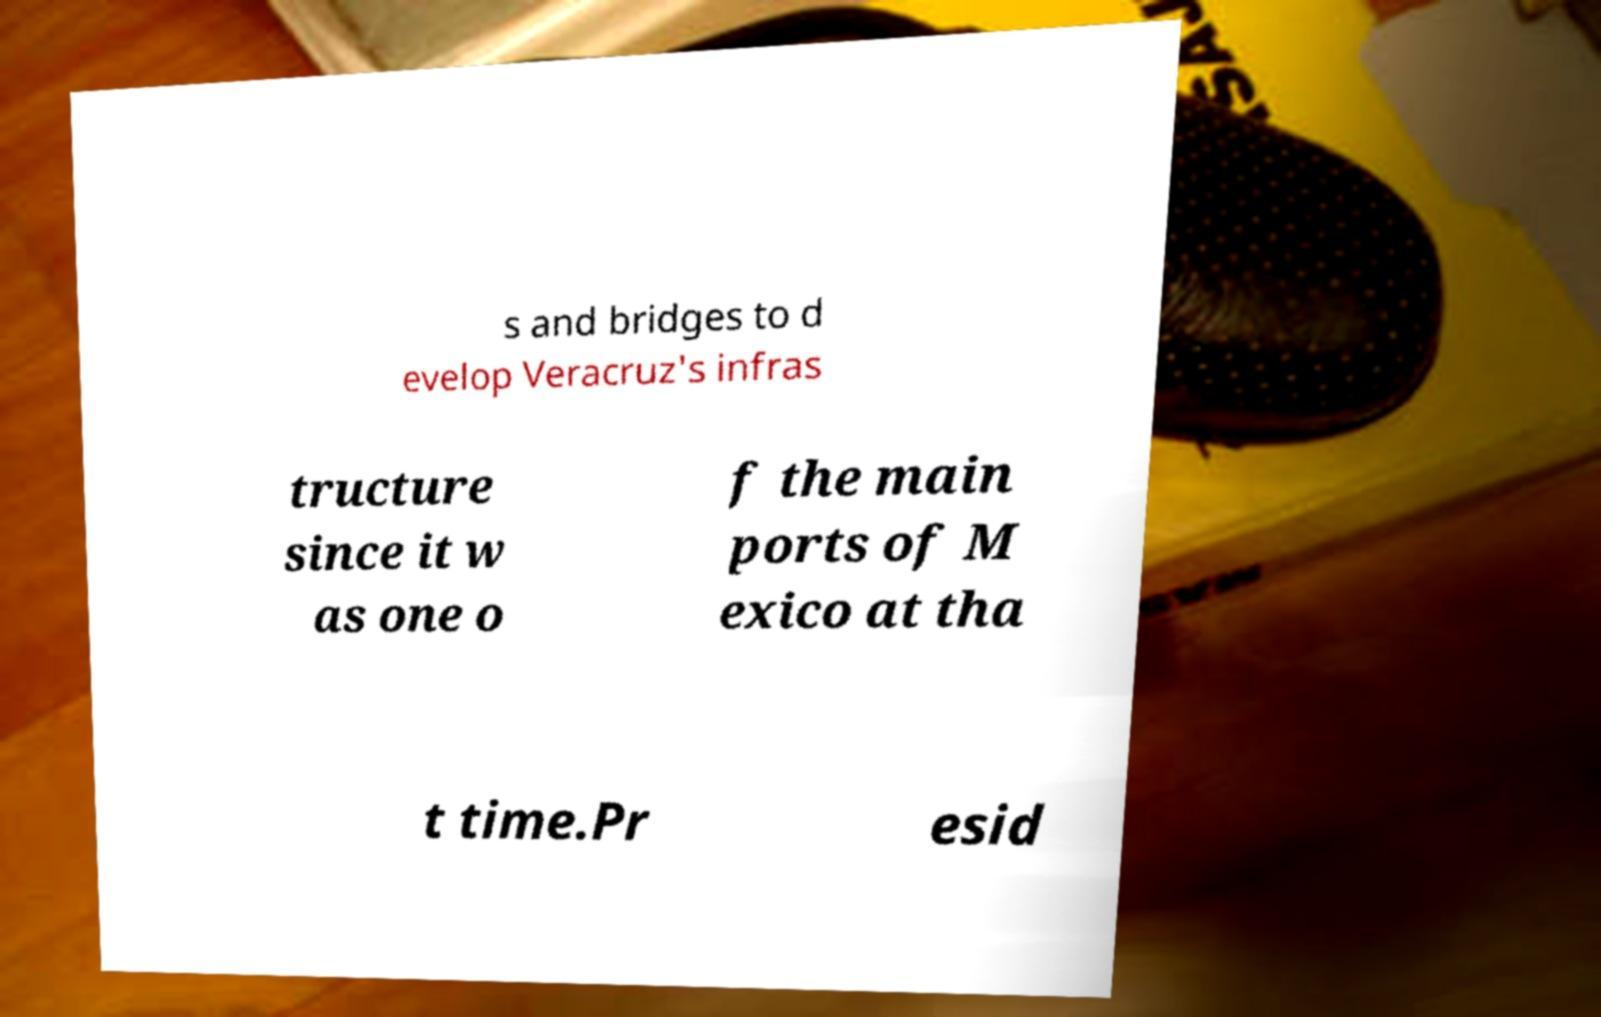I need the written content from this picture converted into text. Can you do that? s and bridges to d evelop Veracruz's infras tructure since it w as one o f the main ports of M exico at tha t time.Pr esid 